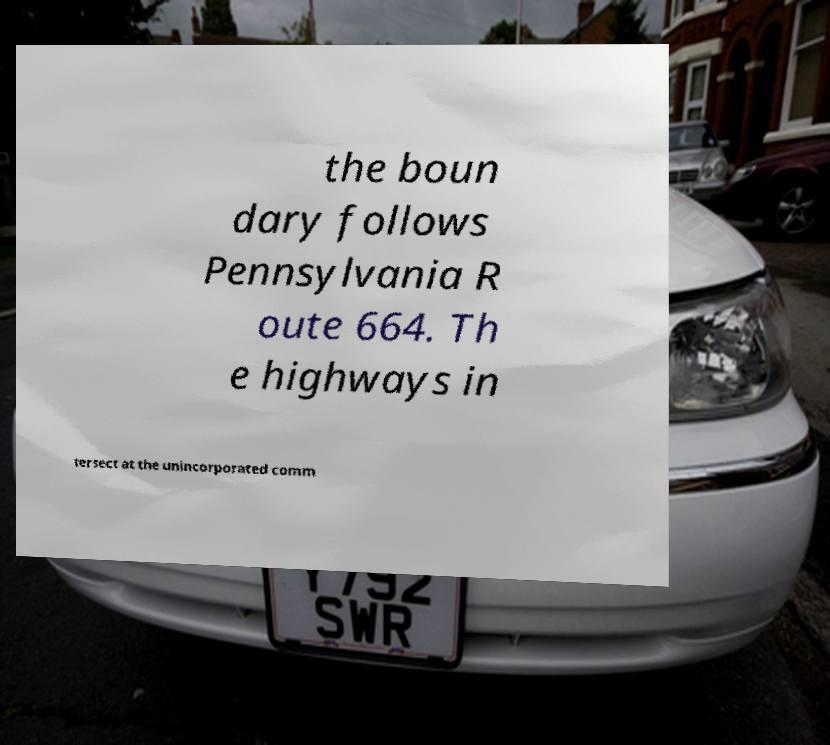Can you accurately transcribe the text from the provided image for me? the boun dary follows Pennsylvania R oute 664. Th e highways in tersect at the unincorporated comm 